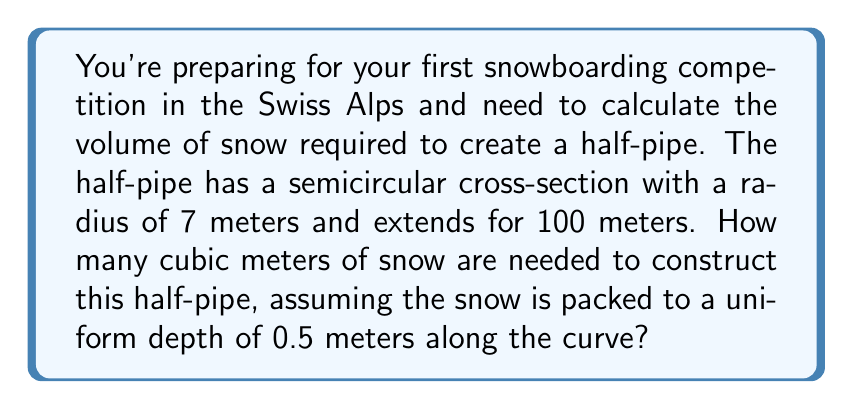Give your solution to this math problem. Let's approach this step-by-step:

1) The half-pipe is essentially half of a cylindrical shell. We need to find the surface area of this half-cylinder and then multiply it by the depth of the snow.

2) The surface area of a half-cylinder (without the flat ends) is given by the formula:

   $A = \pi r L$

   Where $r$ is the radius and $L$ is the length of the cylinder.

3) Given:
   - Radius $(r) = 7$ meters
   - Length $(L) = 100$ meters

4) Let's calculate the surface area:

   $A = \pi \cdot 7 \cdot 100 = 700\pi$ square meters

5) Now, we need to multiply this area by the depth of the snow $(d) = 0.5$ meters to get the volume:

   $V = A \cdot d = 700\pi \cdot 0.5 = 350\pi$ cubic meters

6) To get a numerical value, let's calculate this:

   $V = 350\pi \approx 1099.56$ cubic meters

Therefore, approximately 1099.56 cubic meters of packed snow are needed to create the half-pipe.
Answer: $350\pi \approx 1099.56$ cubic meters of snow 